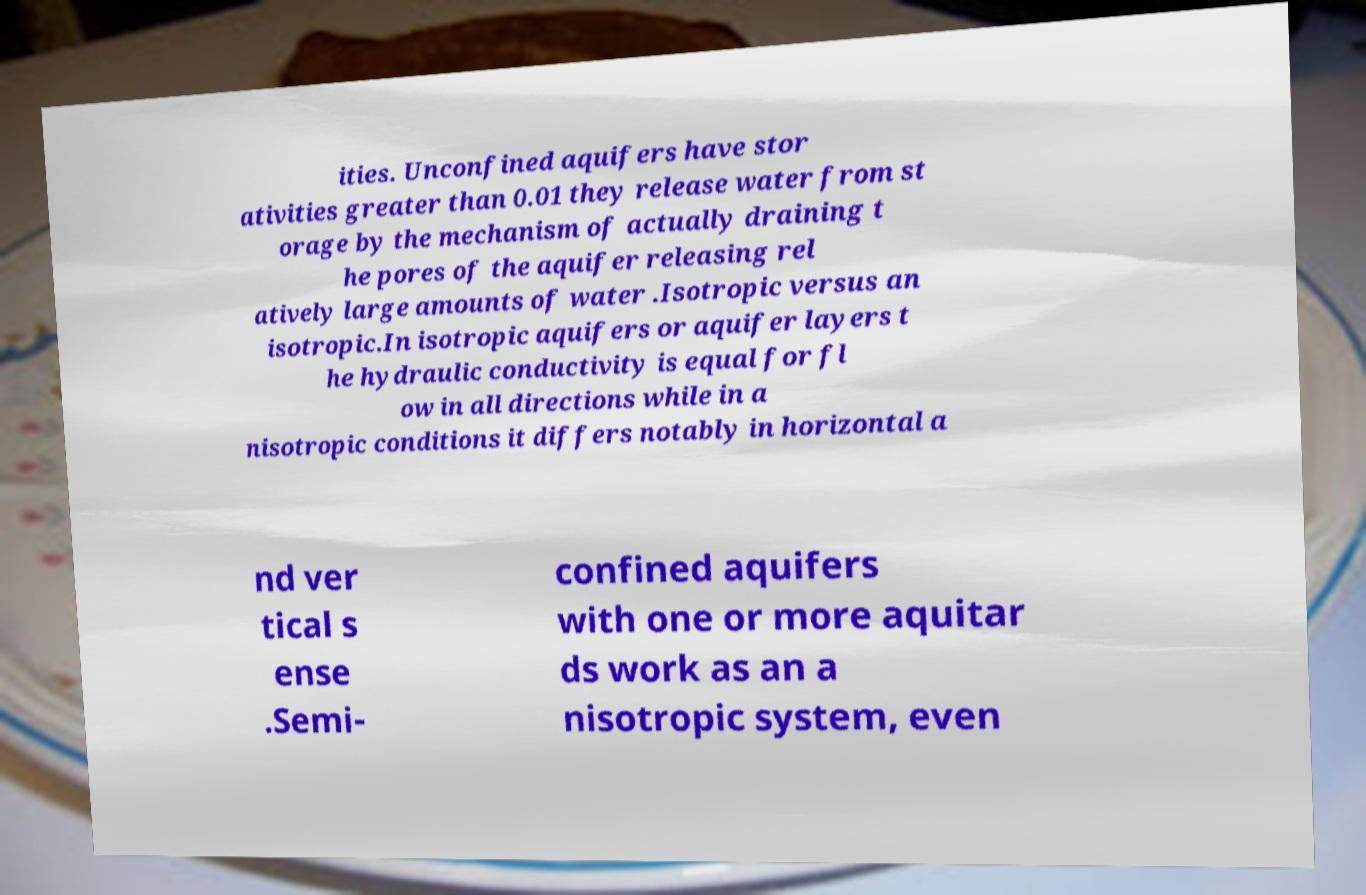Please read and relay the text visible in this image. What does it say? ities. Unconfined aquifers have stor ativities greater than 0.01 they release water from st orage by the mechanism of actually draining t he pores of the aquifer releasing rel atively large amounts of water .Isotropic versus an isotropic.In isotropic aquifers or aquifer layers t he hydraulic conductivity is equal for fl ow in all directions while in a nisotropic conditions it differs notably in horizontal a nd ver tical s ense .Semi- confined aquifers with one or more aquitar ds work as an a nisotropic system, even 